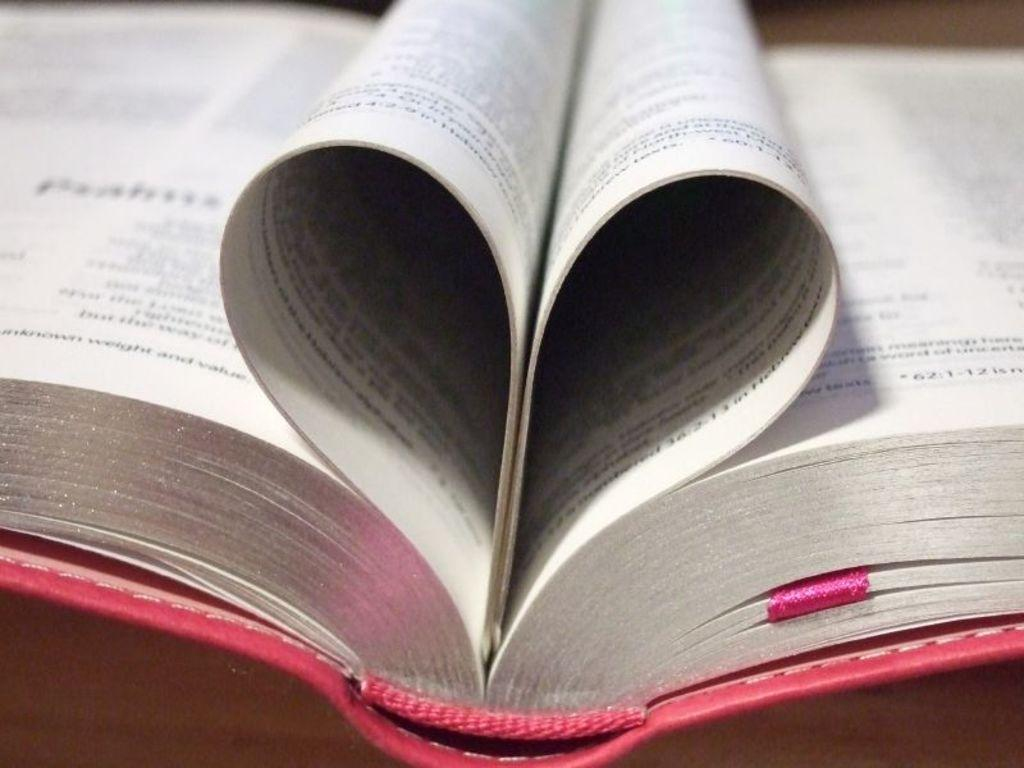Provide a one-sentence caption for the provided image. The pages of opened book is arranged ina heart shape, but the letters are too blurred to make out, except for "62:1-12" on the right side. 